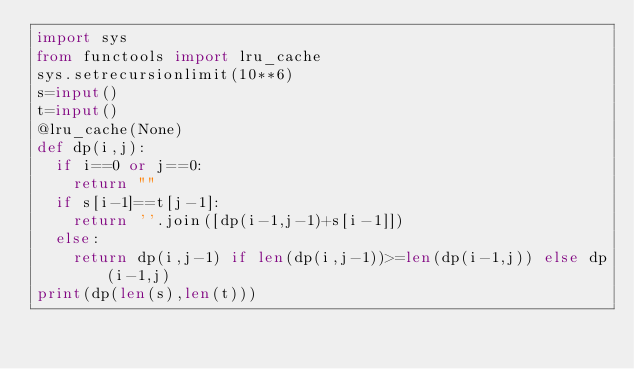<code> <loc_0><loc_0><loc_500><loc_500><_Python_>import sys
from functools import lru_cache
sys.setrecursionlimit(10**6)
s=input()
t=input()
@lru_cache(None)
def dp(i,j):
  if i==0 or j==0:
    return ""
  if s[i-1]==t[j-1]:
    return ''.join([dp(i-1,j-1)+s[i-1]])
  else:
    return dp(i,j-1) if len(dp(i,j-1))>=len(dp(i-1,j)) else dp(i-1,j)
print(dp(len(s),len(t)))
    </code> 